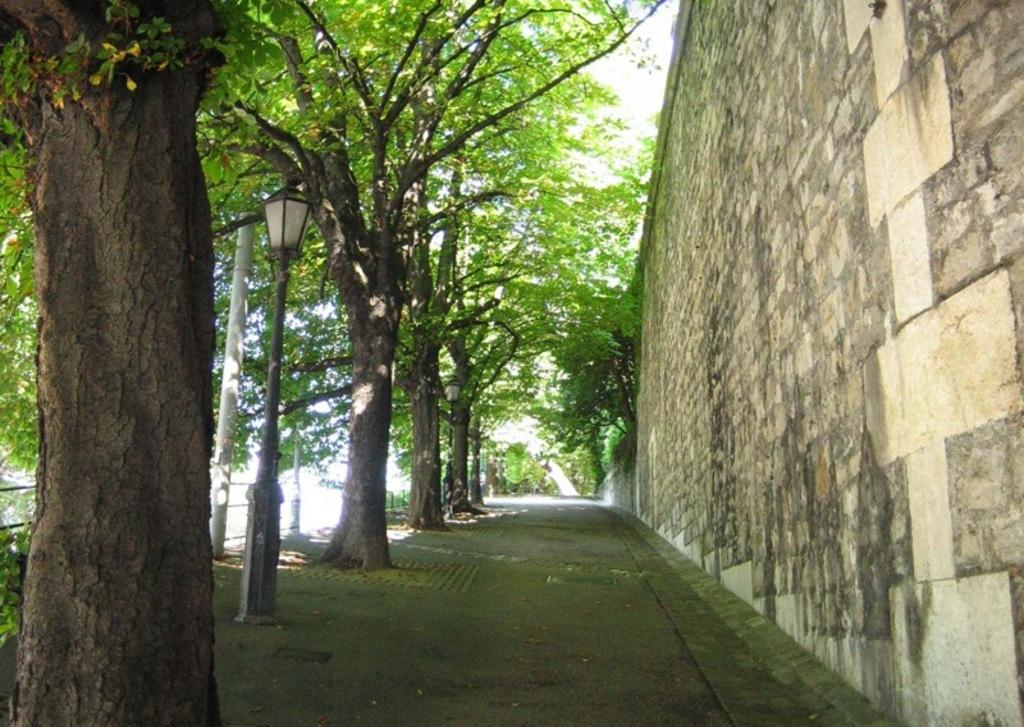What type of vegetation is present in the image? There are green trees in the image. What type of structure can be seen in the image? There is a light pole in the image. What type of barrier is present in the image? There is a wall and fencing in the image. How is the distribution of seats arranged in the image? There are no seats present in the image. What type of weather event is occurring in the image? There is no indication of a rainstorm or any weather event in the image. 